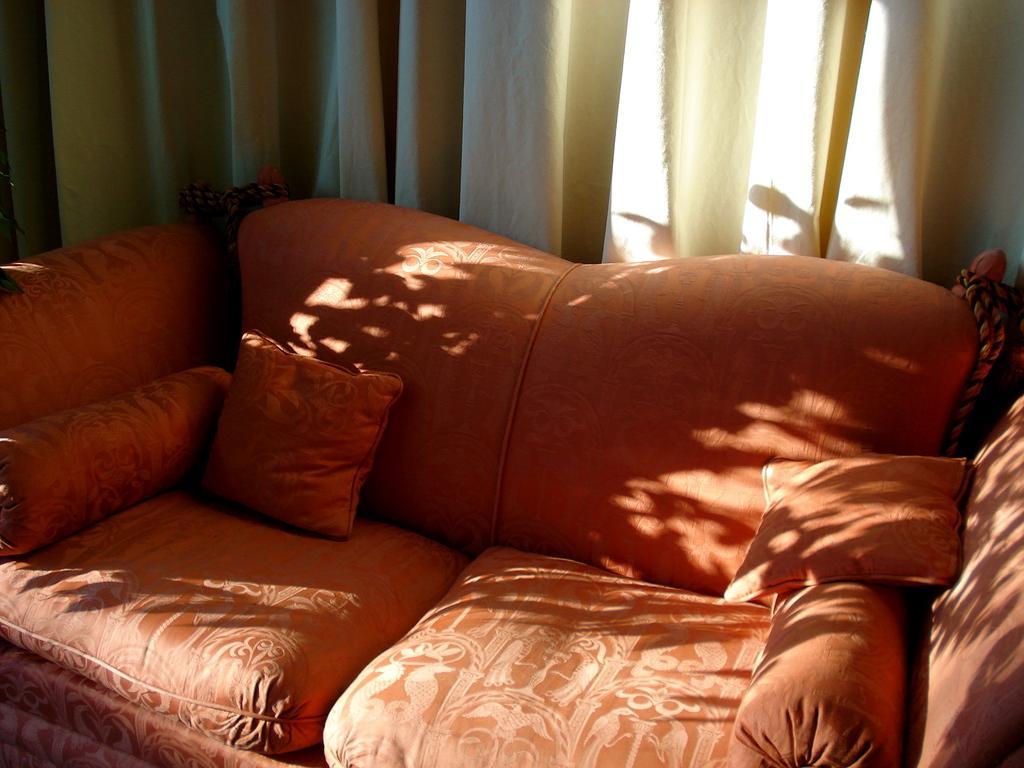In one or two sentences, can you explain what this image depicts? This image is taken inside the room. In this there is a sofa which is in orange color with pillows on it. In the background there is a curtain. 